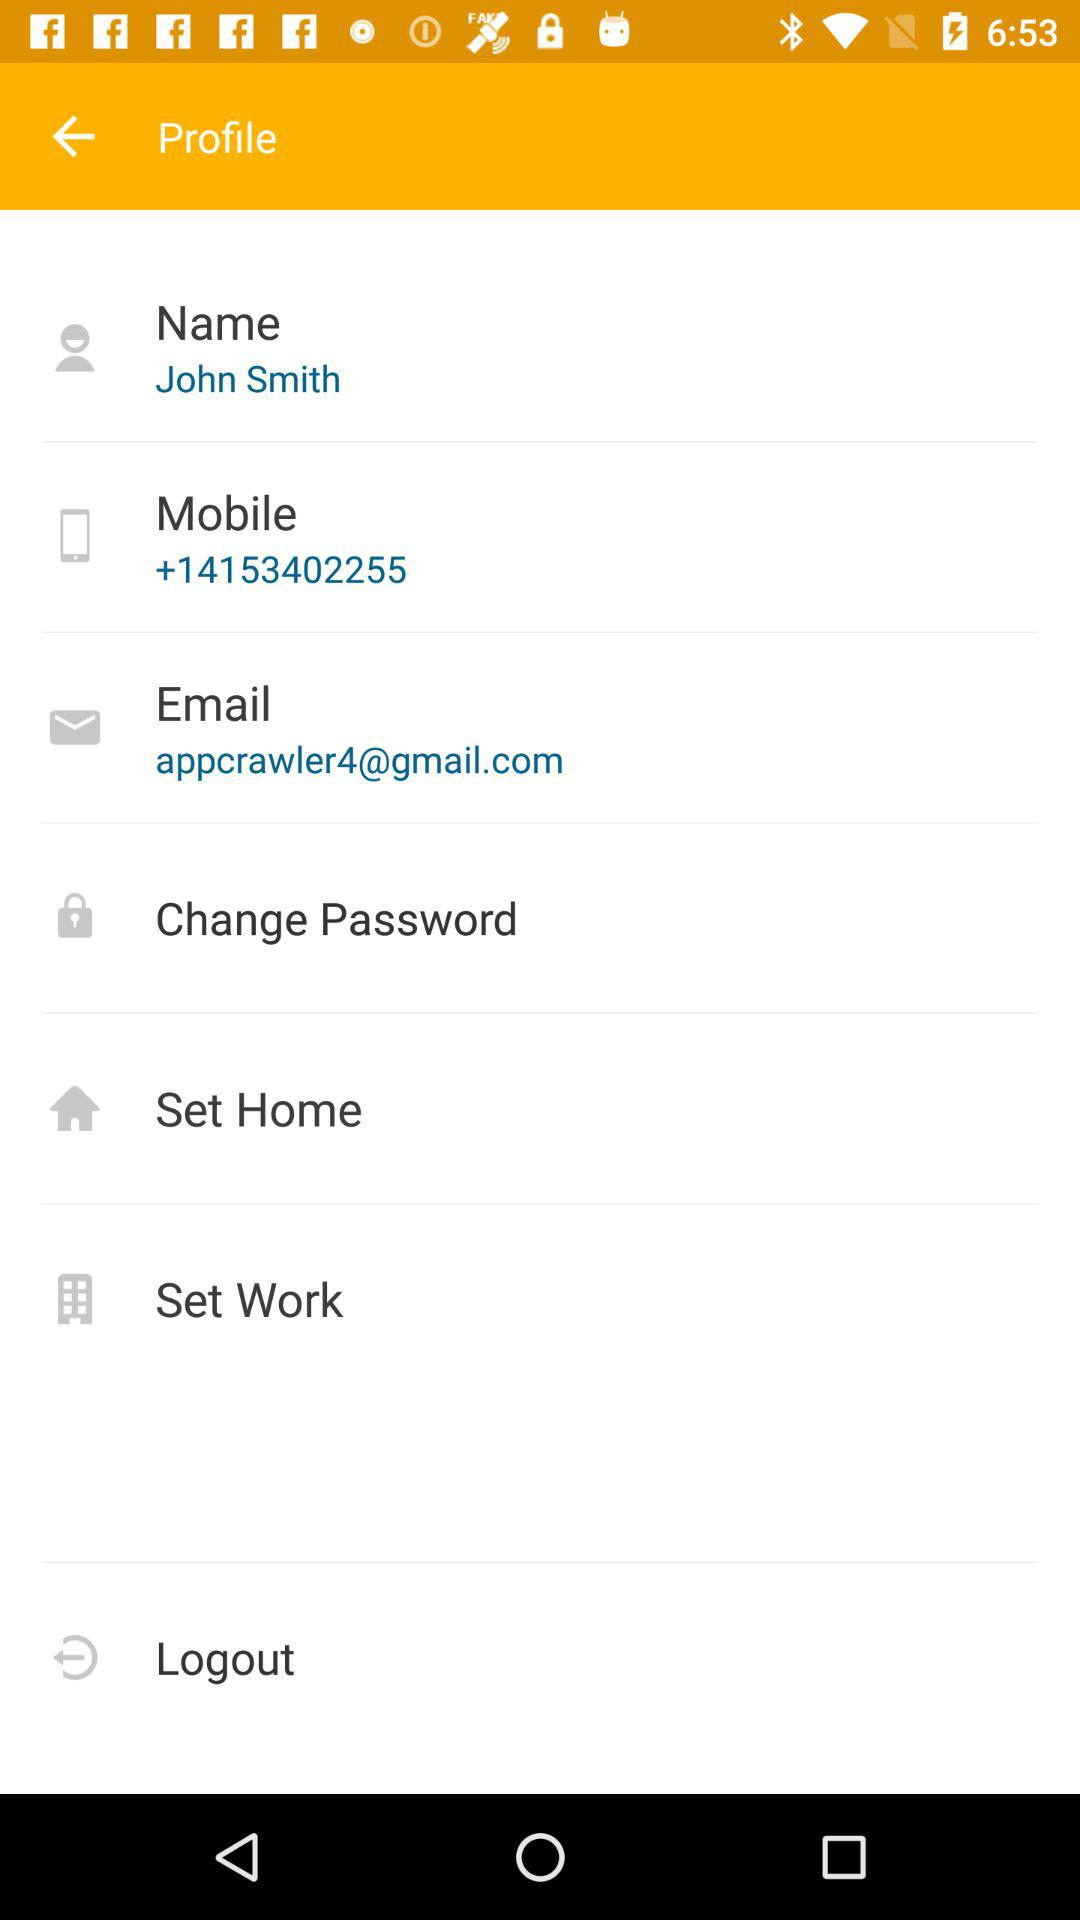What is the profile name? The profile name is John Smith. 